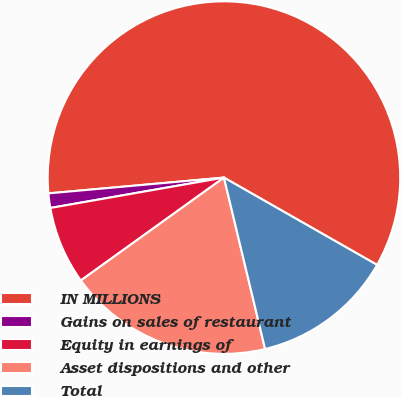Convert chart to OTSL. <chart><loc_0><loc_0><loc_500><loc_500><pie_chart><fcel>IN MILLIONS<fcel>Gains on sales of restaurant<fcel>Equity in earnings of<fcel>Asset dispositions and other<fcel>Total<nl><fcel>59.67%<fcel>1.33%<fcel>7.16%<fcel>18.83%<fcel>13.0%<nl></chart> 